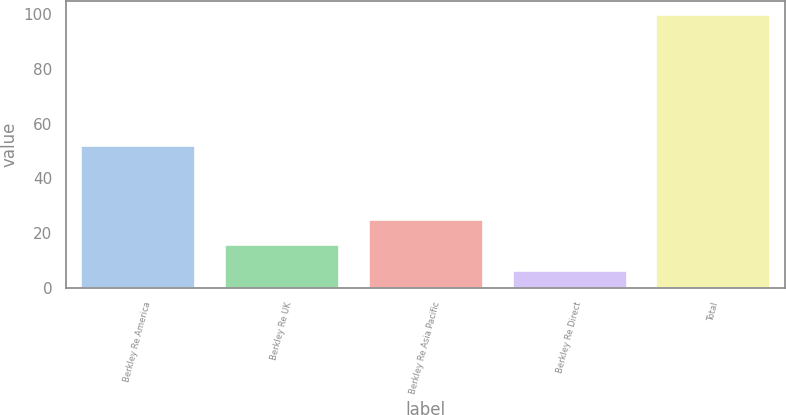Convert chart. <chart><loc_0><loc_0><loc_500><loc_500><bar_chart><fcel>Berkley Re America<fcel>Berkley Re UK<fcel>Berkley Re Asia Pacific<fcel>Berkley Re Direct<fcel>Total<nl><fcel>52.2<fcel>15.85<fcel>25.2<fcel>6.5<fcel>100<nl></chart> 